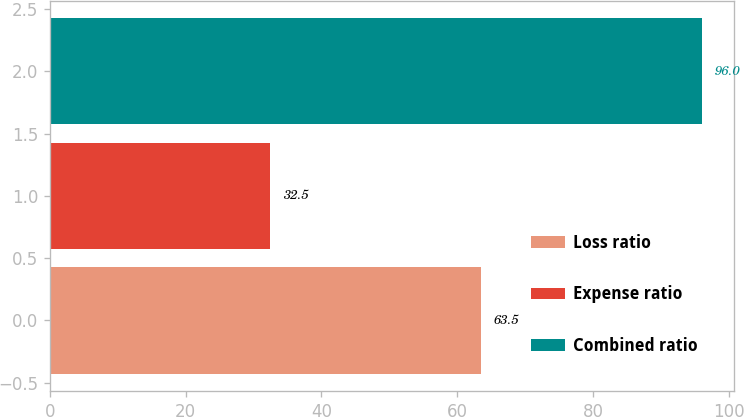Convert chart. <chart><loc_0><loc_0><loc_500><loc_500><bar_chart><fcel>Loss ratio<fcel>Expense ratio<fcel>Combined ratio<nl><fcel>63.5<fcel>32.5<fcel>96<nl></chart> 